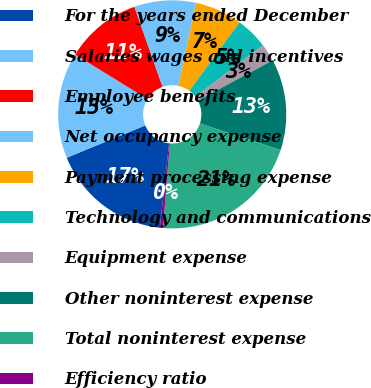Convert chart. <chart><loc_0><loc_0><loc_500><loc_500><pie_chart><fcel>For the years ended December<fcel>Salaries wages and incentives<fcel>Employee benefits<fcel>Net occupancy expense<fcel>Payment processing expense<fcel>Technology and communications<fcel>Equipment expense<fcel>Other noninterest expense<fcel>Total noninterest expense<fcel>Efficiency ratio<nl><fcel>17.07%<fcel>14.99%<fcel>10.83%<fcel>8.75%<fcel>6.67%<fcel>4.59%<fcel>2.51%<fcel>12.91%<fcel>21.23%<fcel>0.43%<nl></chart> 